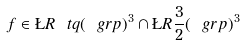<formula> <loc_0><loc_0><loc_500><loc_500>f \in \L R { \ t q } ( \ g r p ) ^ { 3 } \cap \L R { \frac { 3 } { 2 } } ( \ g r p ) ^ { 3 }</formula> 